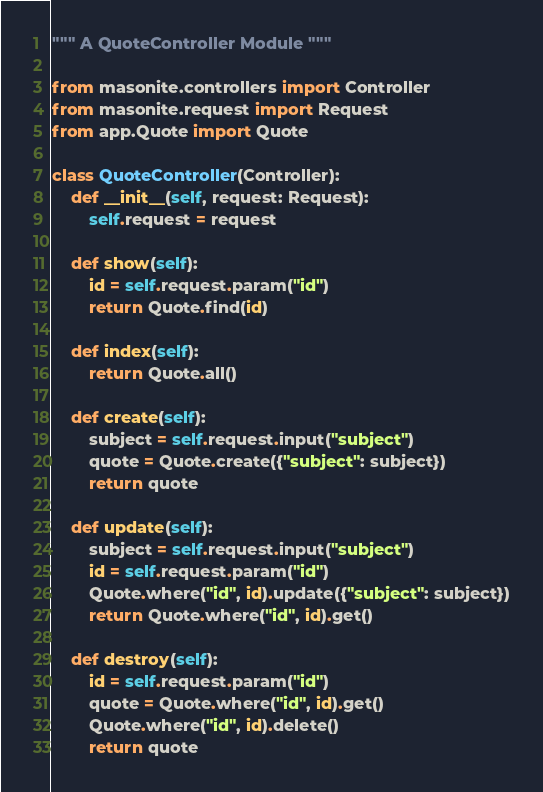<code> <loc_0><loc_0><loc_500><loc_500><_Python_>""" A QuoteController Module """

from masonite.controllers import Controller
from masonite.request import Request
from app.Quote import Quote

class QuoteController(Controller):
    def __init__(self, request: Request):
        self.request = request

    def show(self):
        id = self.request.param("id")
        return Quote.find(id)

    def index(self):
        return Quote.all()

    def create(self):
        subject = self.request.input("subject")
        quote = Quote.create({"subject": subject})
        return quote

    def update(self):
        subject = self.request.input("subject")
        id = self.request.param("id")
        Quote.where("id", id).update({"subject": subject})
        return Quote.where("id", id).get()

    def destroy(self):
        id = self.request.param("id")
        quote = Quote.where("id", id).get()
        Quote.where("id", id).delete()
        return quote
</code> 